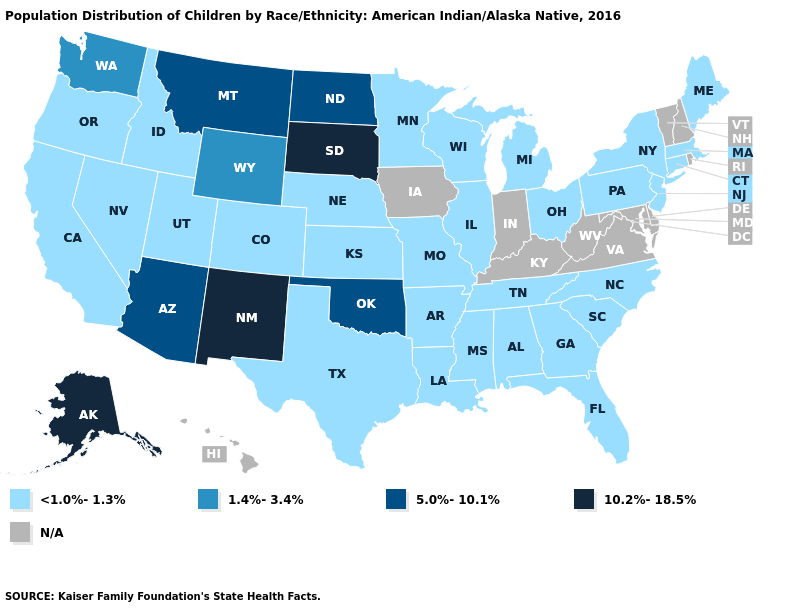Name the states that have a value in the range 1.4%-3.4%?
Answer briefly. Washington, Wyoming. What is the value of Delaware?
Answer briefly. N/A. What is the lowest value in the USA?
Short answer required. <1.0%-1.3%. Among the states that border Montana , which have the lowest value?
Give a very brief answer. Idaho. Name the states that have a value in the range 5.0%-10.1%?
Write a very short answer. Arizona, Montana, North Dakota, Oklahoma. Which states hav the highest value in the South?
Write a very short answer. Oklahoma. Does Kansas have the lowest value in the USA?
Short answer required. Yes. Name the states that have a value in the range 5.0%-10.1%?
Concise answer only. Arizona, Montana, North Dakota, Oklahoma. Name the states that have a value in the range 10.2%-18.5%?
Keep it brief. Alaska, New Mexico, South Dakota. Does New Mexico have the highest value in the West?
Concise answer only. Yes. Among the states that border Utah , which have the lowest value?
Short answer required. Colorado, Idaho, Nevada. What is the lowest value in the USA?
Quick response, please. <1.0%-1.3%. 